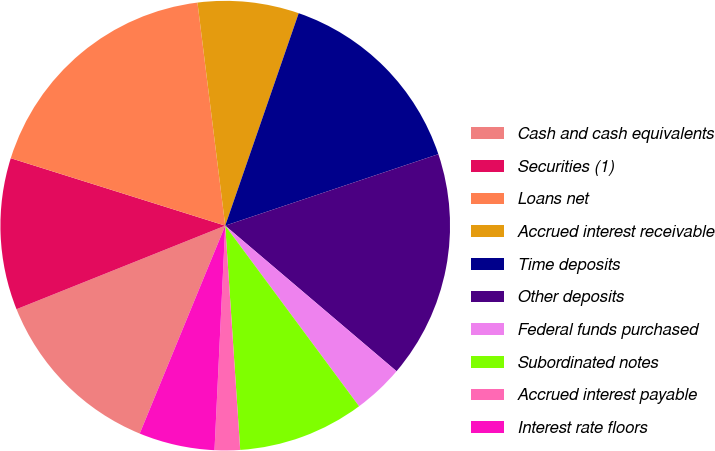<chart> <loc_0><loc_0><loc_500><loc_500><pie_chart><fcel>Cash and cash equivalents<fcel>Securities (1)<fcel>Loans net<fcel>Accrued interest receivable<fcel>Time deposits<fcel>Other deposits<fcel>Federal funds purchased<fcel>Subordinated notes<fcel>Accrued interest payable<fcel>Interest rate floors<nl><fcel>12.73%<fcel>10.91%<fcel>18.18%<fcel>7.27%<fcel>14.55%<fcel>16.36%<fcel>3.64%<fcel>9.09%<fcel>1.82%<fcel>5.45%<nl></chart> 